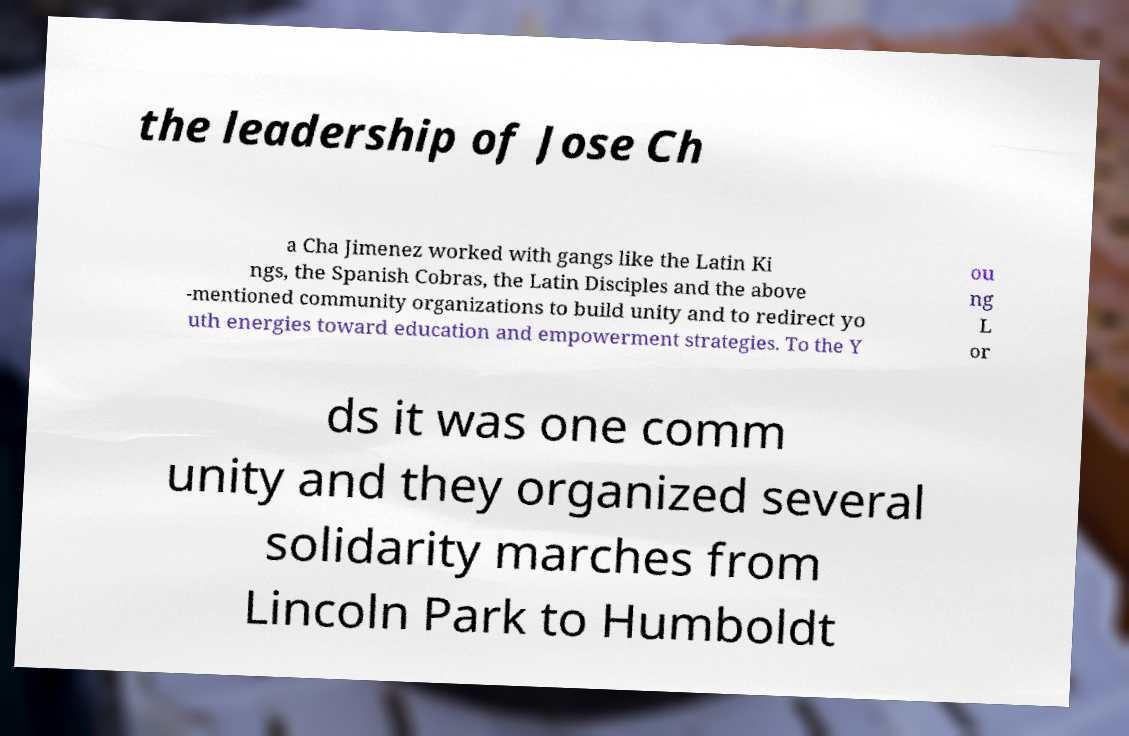Can you read and provide the text displayed in the image?This photo seems to have some interesting text. Can you extract and type it out for me? the leadership of Jose Ch a Cha Jimenez worked with gangs like the Latin Ki ngs, the Spanish Cobras, the Latin Disciples and the above -mentioned community organizations to build unity and to redirect yo uth energies toward education and empowerment strategies. To the Y ou ng L or ds it was one comm unity and they organized several solidarity marches from Lincoln Park to Humboldt 